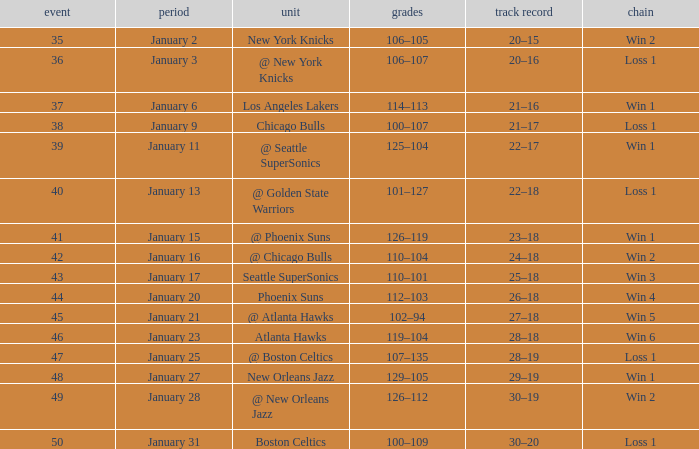What is the Team on January 20? Phoenix Suns. 